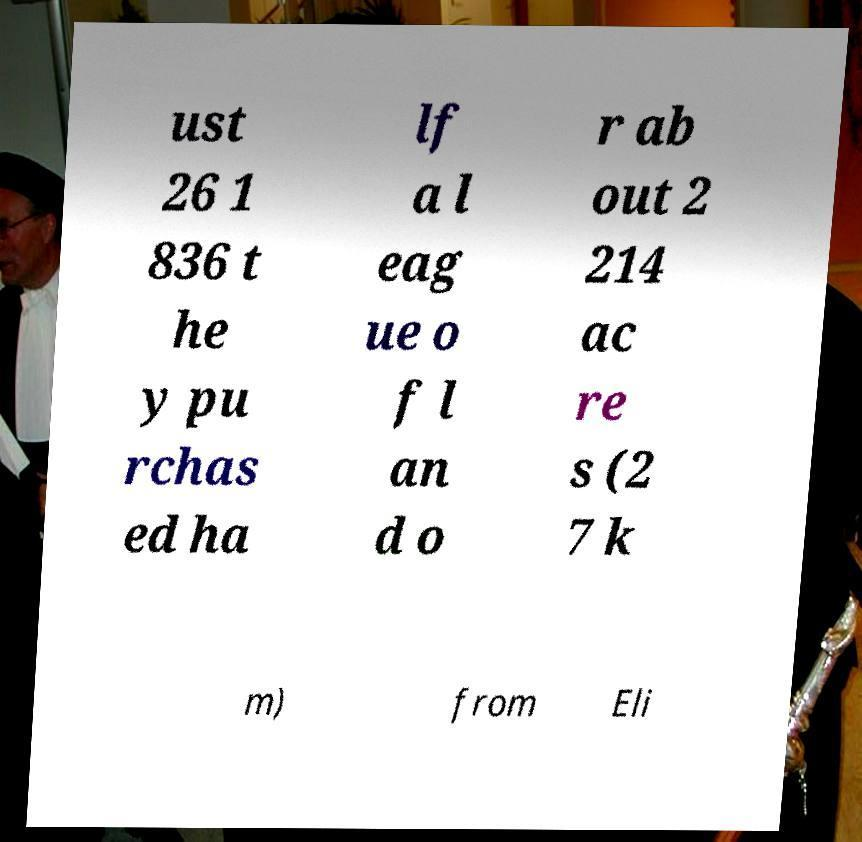Please identify and transcribe the text found in this image. ust 26 1 836 t he y pu rchas ed ha lf a l eag ue o f l an d o r ab out 2 214 ac re s (2 7 k m) from Eli 